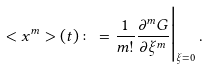<formula> <loc_0><loc_0><loc_500><loc_500>< x ^ { m } > ( t ) \colon = \frac { 1 } { m ! } \frac { \partial ^ { m } G } { \partial \xi ^ { m } } \Big | _ { \xi = 0 } \, .</formula> 